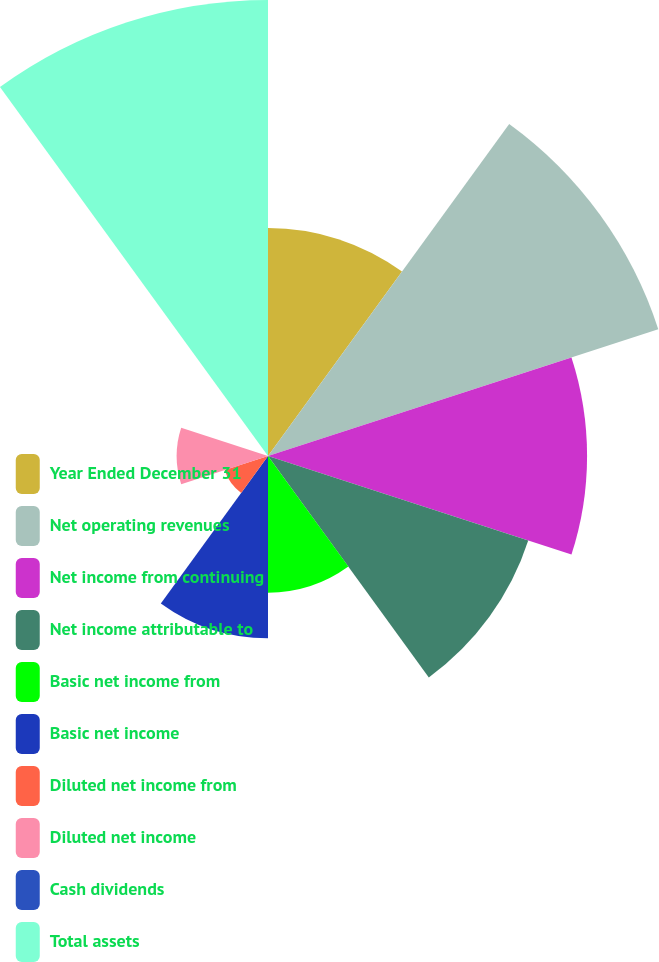Convert chart to OTSL. <chart><loc_0><loc_0><loc_500><loc_500><pie_chart><fcel>Year Ended December 31<fcel>Net operating revenues<fcel>Net income from continuing<fcel>Net income attributable to<fcel>Basic net income from<fcel>Basic net income<fcel>Diluted net income from<fcel>Diluted net income<fcel>Cash dividends<fcel>Total assets<nl><fcel>10.64%<fcel>19.15%<fcel>14.89%<fcel>12.77%<fcel>6.38%<fcel>8.51%<fcel>2.13%<fcel>4.26%<fcel>0.0%<fcel>21.28%<nl></chart> 